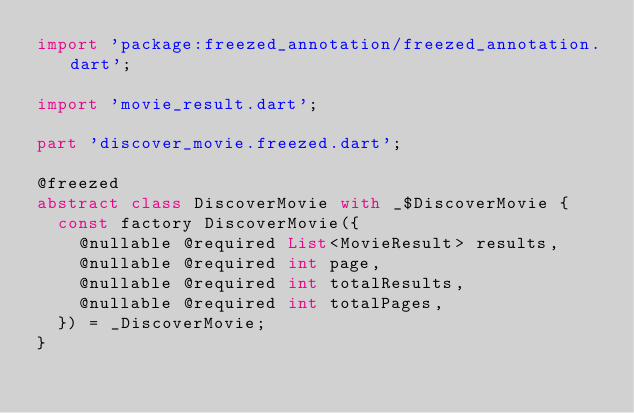Convert code to text. <code><loc_0><loc_0><loc_500><loc_500><_Dart_>import 'package:freezed_annotation/freezed_annotation.dart';

import 'movie_result.dart';

part 'discover_movie.freezed.dart';

@freezed
abstract class DiscoverMovie with _$DiscoverMovie {
  const factory DiscoverMovie({
    @nullable @required List<MovieResult> results,
    @nullable @required int page,
    @nullable @required int totalResults,
    @nullable @required int totalPages,
  }) = _DiscoverMovie;
}
</code> 